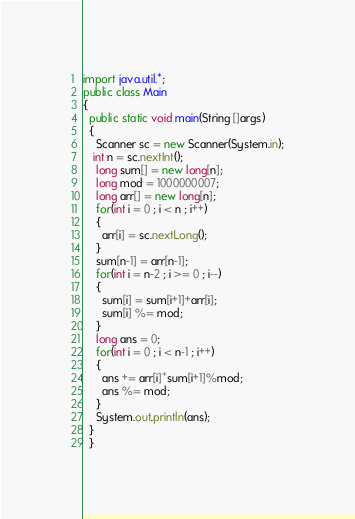Convert code to text. <code><loc_0><loc_0><loc_500><loc_500><_Java_>import java.util.*;
public class Main
{
  public static void main(String []args)
  {
    Scanner sc = new Scanner(System.in);
   int n = sc.nextInt();
    long sum[] = new long[n];
    long mod = 1000000007;
    long arr[] = new long[n];
    for(int i = 0 ; i < n ; i++)
    {
      arr[i] = sc.nextLong();
    }
    sum[n-1] = arr[n-1];
    for(int i = n-2 ; i >= 0 ; i--)
    {
      sum[i] = sum[i+1]+arr[i];
      sum[i] %= mod;
    }
    long ans = 0;
    for(int i = 0 ; i < n-1 ; i++)
    {
      ans += arr[i]*sum[i+1]%mod;
      ans %= mod;
    }
    System.out.println(ans);
  }
  }
</code> 